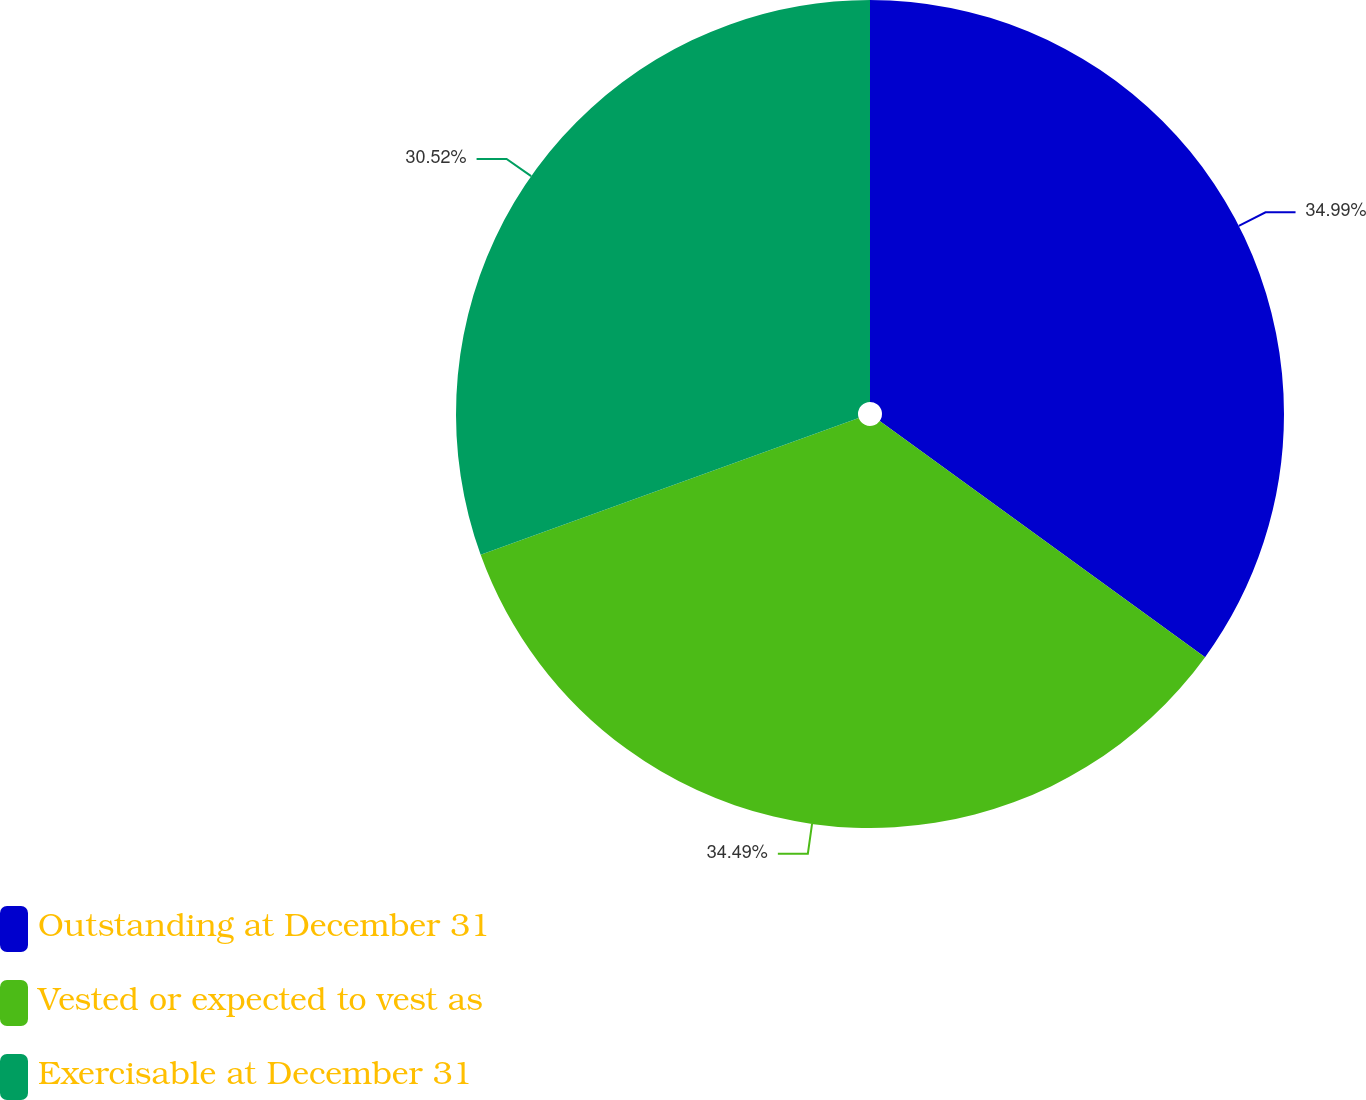Convert chart to OTSL. <chart><loc_0><loc_0><loc_500><loc_500><pie_chart><fcel>Outstanding at December 31<fcel>Vested or expected to vest as<fcel>Exercisable at December 31<nl><fcel>34.99%<fcel>34.49%<fcel>30.52%<nl></chart> 